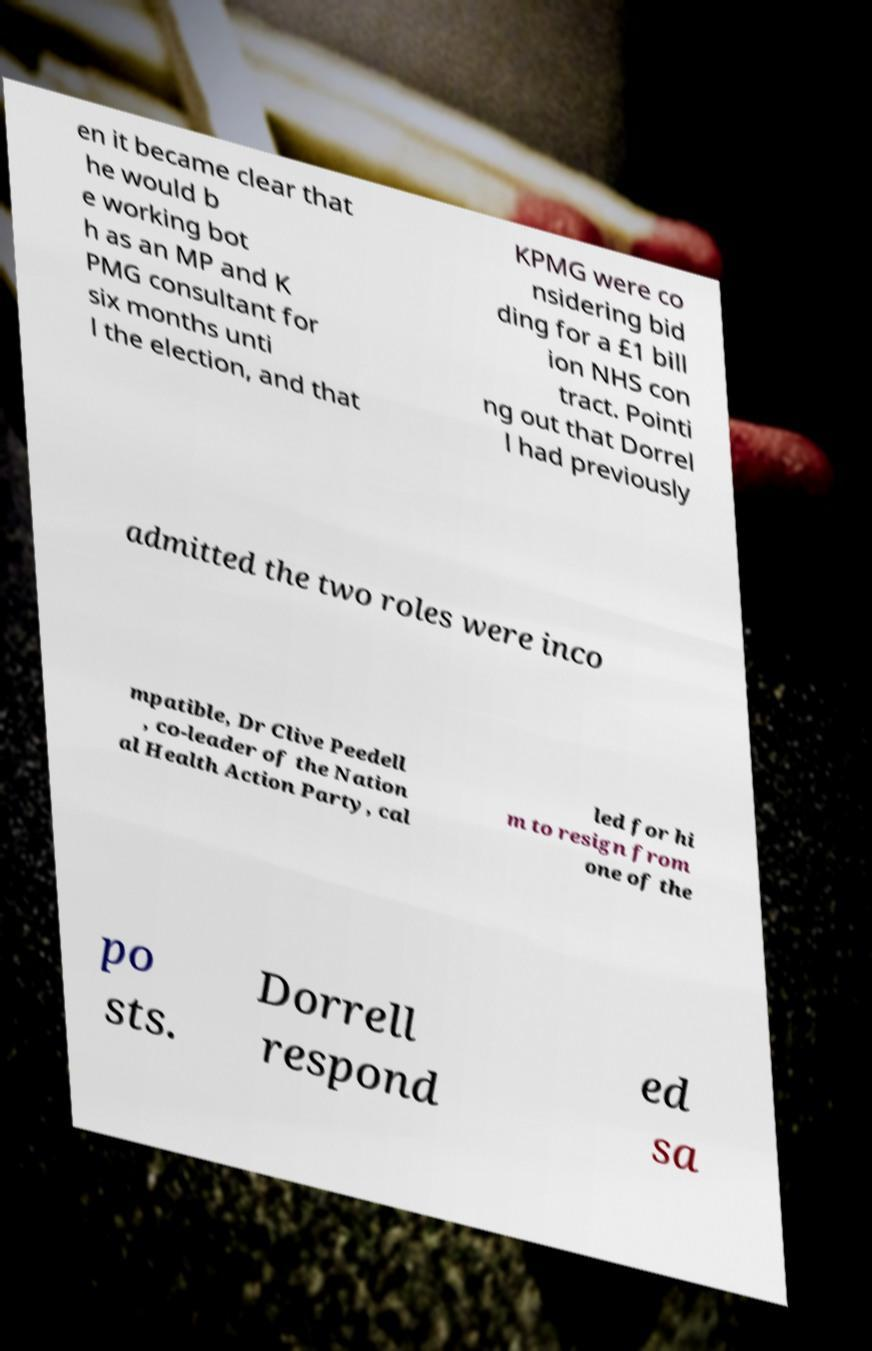Could you extract and type out the text from this image? en it became clear that he would b e working bot h as an MP and K PMG consultant for six months unti l the election, and that KPMG were co nsidering bid ding for a £1 bill ion NHS con tract. Pointi ng out that Dorrel l had previously admitted the two roles were inco mpatible, Dr Clive Peedell , co-leader of the Nation al Health Action Party, cal led for hi m to resign from one of the po sts. Dorrell respond ed sa 